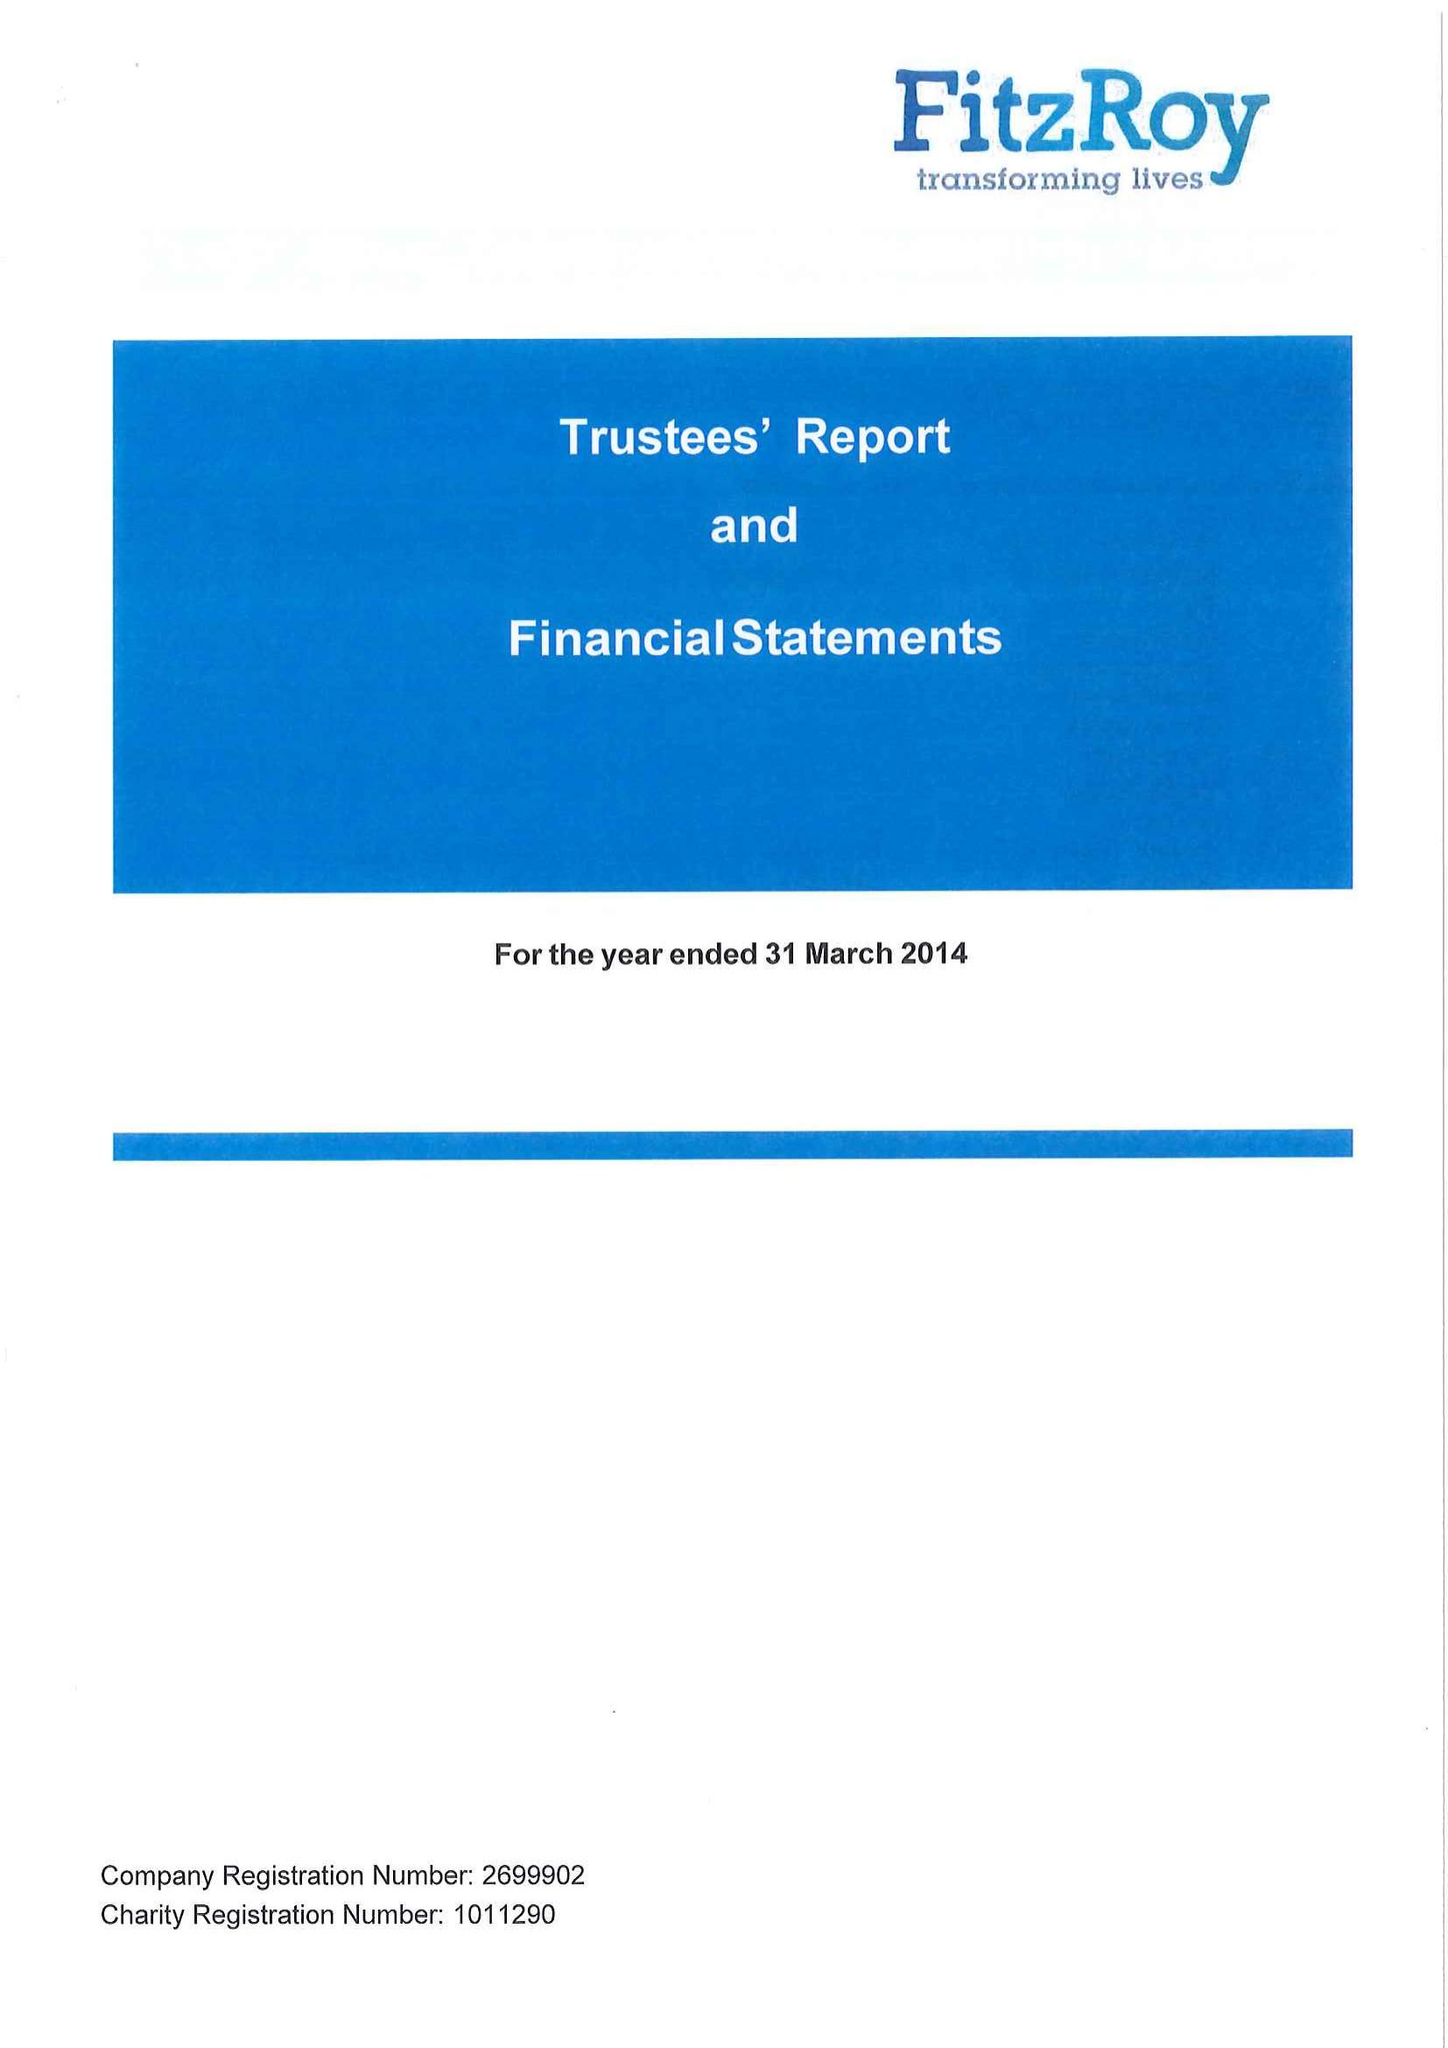What is the value for the address__street_line?
Answer the question using a single word or phrase. 8 HYLTON ROAD 